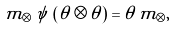Convert formula to latex. <formula><loc_0><loc_0><loc_500><loc_500>m _ { \otimes } \, \psi \, \left ( \theta \otimes \theta \right ) = \theta \, m _ { \otimes } ,</formula> 